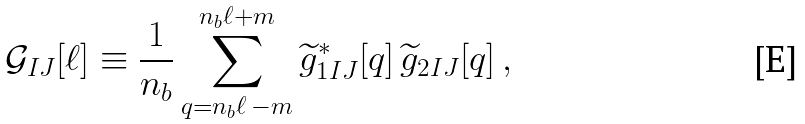<formula> <loc_0><loc_0><loc_500><loc_500>\mathcal { G } _ { I J } [ \ell ] \equiv \frac { 1 } { n _ { b } } \sum _ { q = n _ { b } \ell \, - m } ^ { n _ { b } \ell + m } \widetilde { g } ^ { * } _ { 1 I J } [ q ] \, \widetilde { g } _ { 2 I J } [ q ] \, ,</formula> 